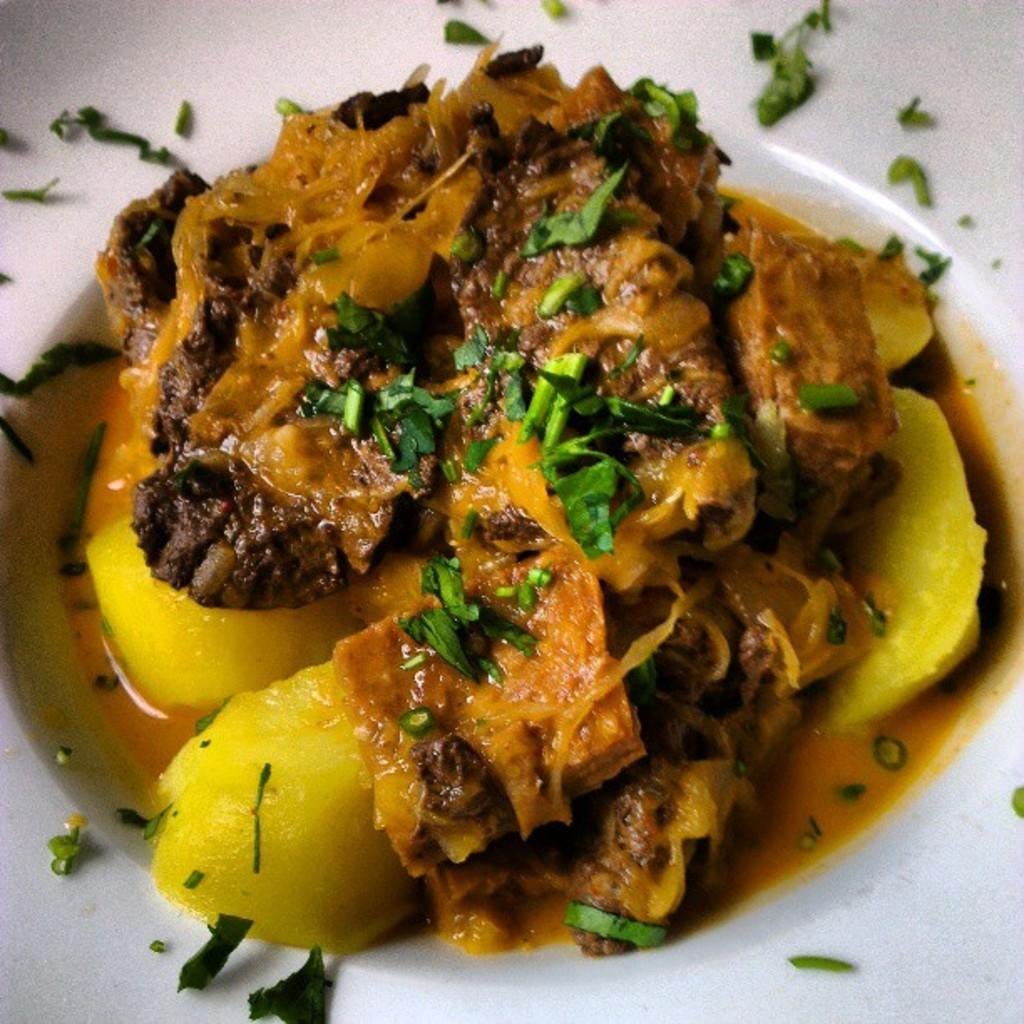What is the main subject of the image? There is a food item in the image. How is the food item presented in the image? The food item is on a white color plate. What type of question is being asked in the image? There is no question present in the image; it features a food item on a white color plate. Can you see a hook attached to the food item in the image? There is no hook attached to the food item in the image. 